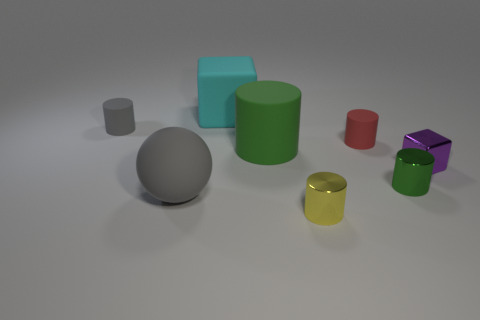Subtract all large matte cylinders. How many cylinders are left? 4 Subtract all green blocks. How many green cylinders are left? 2 Subtract 1 cylinders. How many cylinders are left? 4 Subtract all gray cylinders. How many cylinders are left? 4 Add 2 large gray balls. How many objects exist? 10 Subtract all brown cylinders. Subtract all red cubes. How many cylinders are left? 5 Subtract all balls. How many objects are left? 7 Subtract all tiny yellow rubber objects. Subtract all tiny shiny cylinders. How many objects are left? 6 Add 4 green metal objects. How many green metal objects are left? 5 Add 5 small blue shiny blocks. How many small blue shiny blocks exist? 5 